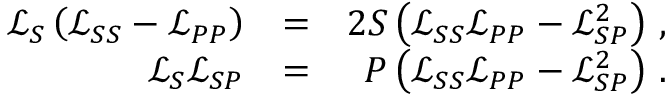Convert formula to latex. <formula><loc_0><loc_0><loc_500><loc_500>\begin{array} { r l r } { \mathcal { L } _ { S } \left ( \mathcal { L } _ { S S } - \mathcal { L } _ { P P } \right ) } & { = } & { 2 S \left ( \mathcal { L } _ { S S } \mathcal { L } _ { P P } - \mathcal { L } _ { S P } ^ { 2 } \right ) \, , } \\ { \mathcal { L } _ { S } \mathcal { L } _ { S P } } & { = } & { P \left ( \mathcal { L } _ { S S } \mathcal { L } _ { P P } - \mathcal { L } _ { S P } ^ { 2 } \right ) \, . } \end{array}</formula> 